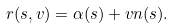<formula> <loc_0><loc_0><loc_500><loc_500>r ( s , v ) = \alpha ( s ) + v n ( s ) .</formula> 